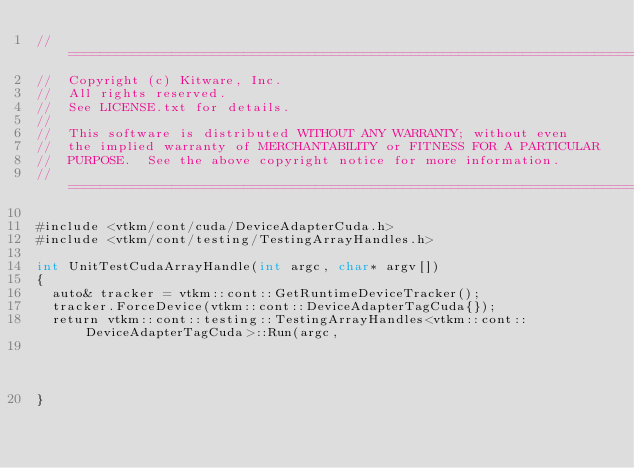<code> <loc_0><loc_0><loc_500><loc_500><_Cuda_>//============================================================================
//  Copyright (c) Kitware, Inc.
//  All rights reserved.
//  See LICENSE.txt for details.
//
//  This software is distributed WITHOUT ANY WARRANTY; without even
//  the implied warranty of MERCHANTABILITY or FITNESS FOR A PARTICULAR
//  PURPOSE.  See the above copyright notice for more information.
//============================================================================

#include <vtkm/cont/cuda/DeviceAdapterCuda.h>
#include <vtkm/cont/testing/TestingArrayHandles.h>

int UnitTestCudaArrayHandle(int argc, char* argv[])
{
  auto& tracker = vtkm::cont::GetRuntimeDeviceTracker();
  tracker.ForceDevice(vtkm::cont::DeviceAdapterTagCuda{});
  return vtkm::cont::testing::TestingArrayHandles<vtkm::cont::DeviceAdapterTagCuda>::Run(argc,
                                                                                         argv);
}
</code> 